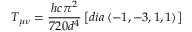<formula> <loc_0><loc_0><loc_500><loc_500>T _ { \mu \nu } = \frac { h c \pi ^ { 2 } } { 7 2 0 d ^ { 4 } } \left [ d i a \left ( - 1 , - 3 , 1 , 1 \right ) \right ]</formula> 